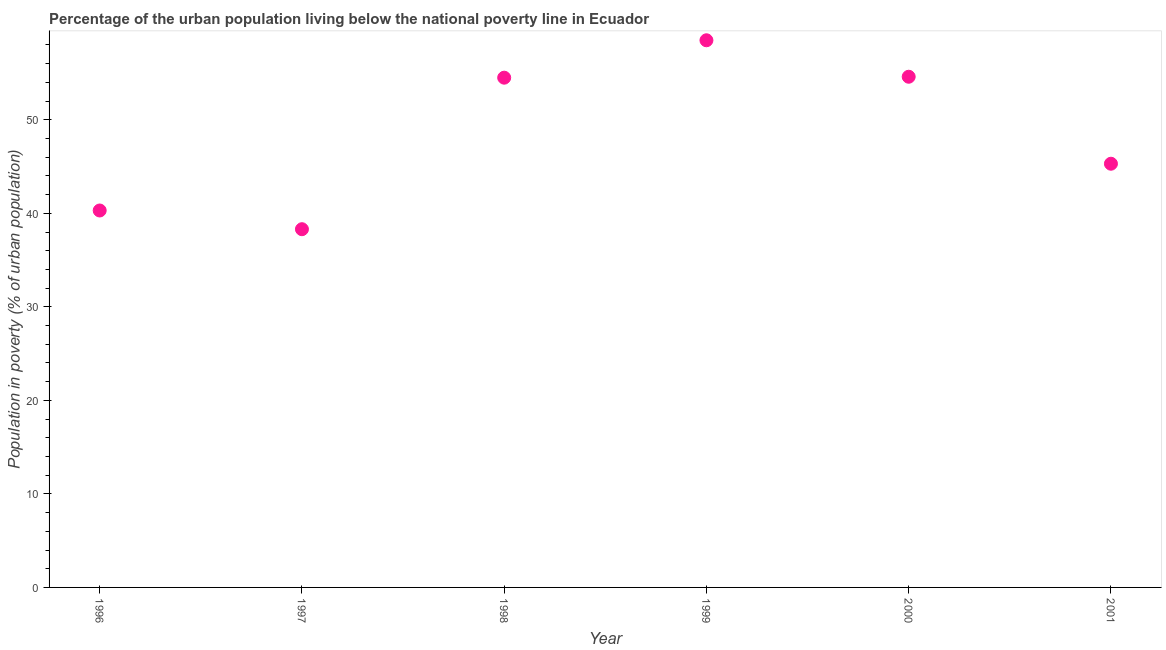What is the percentage of urban population living below poverty line in 1999?
Your response must be concise. 58.5. Across all years, what is the maximum percentage of urban population living below poverty line?
Offer a very short reply. 58.5. Across all years, what is the minimum percentage of urban population living below poverty line?
Give a very brief answer. 38.3. In which year was the percentage of urban population living below poverty line minimum?
Your answer should be compact. 1997. What is the sum of the percentage of urban population living below poverty line?
Provide a short and direct response. 291.5. What is the difference between the percentage of urban population living below poverty line in 1999 and 2001?
Offer a very short reply. 13.2. What is the average percentage of urban population living below poverty line per year?
Keep it short and to the point. 48.58. What is the median percentage of urban population living below poverty line?
Your answer should be very brief. 49.9. In how many years, is the percentage of urban population living below poverty line greater than 48 %?
Provide a succinct answer. 3. What is the ratio of the percentage of urban population living below poverty line in 1996 to that in 1998?
Your answer should be compact. 0.74. Is the percentage of urban population living below poverty line in 1996 less than that in 2001?
Offer a terse response. Yes. Is the difference between the percentage of urban population living below poverty line in 1998 and 1999 greater than the difference between any two years?
Your answer should be very brief. No. What is the difference between the highest and the second highest percentage of urban population living below poverty line?
Make the answer very short. 3.9. Is the sum of the percentage of urban population living below poverty line in 1999 and 2000 greater than the maximum percentage of urban population living below poverty line across all years?
Provide a short and direct response. Yes. What is the difference between the highest and the lowest percentage of urban population living below poverty line?
Keep it short and to the point. 20.2. In how many years, is the percentage of urban population living below poverty line greater than the average percentage of urban population living below poverty line taken over all years?
Provide a succinct answer. 3. Does the percentage of urban population living below poverty line monotonically increase over the years?
Your answer should be compact. No. How many dotlines are there?
Provide a succinct answer. 1. How many years are there in the graph?
Your response must be concise. 6. What is the difference between two consecutive major ticks on the Y-axis?
Offer a terse response. 10. Does the graph contain any zero values?
Give a very brief answer. No. What is the title of the graph?
Provide a short and direct response. Percentage of the urban population living below the national poverty line in Ecuador. What is the label or title of the Y-axis?
Your response must be concise. Population in poverty (% of urban population). What is the Population in poverty (% of urban population) in 1996?
Offer a terse response. 40.3. What is the Population in poverty (% of urban population) in 1997?
Offer a terse response. 38.3. What is the Population in poverty (% of urban population) in 1998?
Your answer should be very brief. 54.5. What is the Population in poverty (% of urban population) in 1999?
Keep it short and to the point. 58.5. What is the Population in poverty (% of urban population) in 2000?
Make the answer very short. 54.6. What is the Population in poverty (% of urban population) in 2001?
Provide a short and direct response. 45.3. What is the difference between the Population in poverty (% of urban population) in 1996 and 1999?
Offer a very short reply. -18.2. What is the difference between the Population in poverty (% of urban population) in 1996 and 2000?
Offer a very short reply. -14.3. What is the difference between the Population in poverty (% of urban population) in 1997 and 1998?
Offer a very short reply. -16.2. What is the difference between the Population in poverty (% of urban population) in 1997 and 1999?
Your response must be concise. -20.2. What is the difference between the Population in poverty (% of urban population) in 1997 and 2000?
Make the answer very short. -16.3. What is the difference between the Population in poverty (% of urban population) in 1999 and 2001?
Provide a succinct answer. 13.2. What is the difference between the Population in poverty (% of urban population) in 2000 and 2001?
Ensure brevity in your answer.  9.3. What is the ratio of the Population in poverty (% of urban population) in 1996 to that in 1997?
Keep it short and to the point. 1.05. What is the ratio of the Population in poverty (% of urban population) in 1996 to that in 1998?
Your answer should be very brief. 0.74. What is the ratio of the Population in poverty (% of urban population) in 1996 to that in 1999?
Give a very brief answer. 0.69. What is the ratio of the Population in poverty (% of urban population) in 1996 to that in 2000?
Keep it short and to the point. 0.74. What is the ratio of the Population in poverty (% of urban population) in 1996 to that in 2001?
Provide a short and direct response. 0.89. What is the ratio of the Population in poverty (% of urban population) in 1997 to that in 1998?
Your answer should be very brief. 0.7. What is the ratio of the Population in poverty (% of urban population) in 1997 to that in 1999?
Make the answer very short. 0.66. What is the ratio of the Population in poverty (% of urban population) in 1997 to that in 2000?
Keep it short and to the point. 0.7. What is the ratio of the Population in poverty (% of urban population) in 1997 to that in 2001?
Your answer should be very brief. 0.84. What is the ratio of the Population in poverty (% of urban population) in 1998 to that in 1999?
Make the answer very short. 0.93. What is the ratio of the Population in poverty (% of urban population) in 1998 to that in 2000?
Make the answer very short. 1. What is the ratio of the Population in poverty (% of urban population) in 1998 to that in 2001?
Your answer should be very brief. 1.2. What is the ratio of the Population in poverty (% of urban population) in 1999 to that in 2000?
Your answer should be very brief. 1.07. What is the ratio of the Population in poverty (% of urban population) in 1999 to that in 2001?
Provide a short and direct response. 1.29. What is the ratio of the Population in poverty (% of urban population) in 2000 to that in 2001?
Your answer should be very brief. 1.21. 